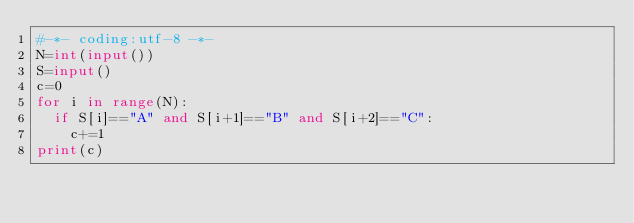<code> <loc_0><loc_0><loc_500><loc_500><_Python_>#-*- coding:utf-8 -*-
N=int(input())
S=input()
c=0
for i in range(N):
  if S[i]=="A" and S[i+1]=="B" and S[i+2]=="C":
    c+=1
print(c)</code> 